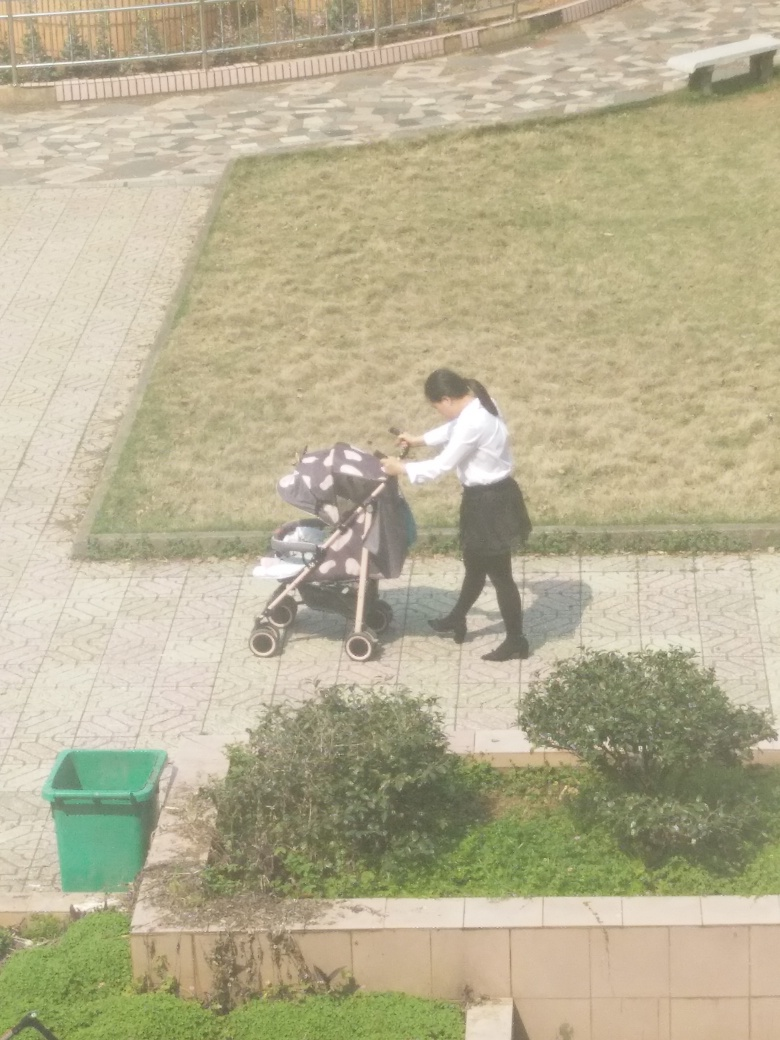It seems quite sunny, but the person is not wearing sunglasses. Can we infer something from this? While sunglasses are common on sunny days to protect eyes from glare, not everyone chooses to wear them. This could be due to personal preference, not having a pair on hand, or not being bothered by the brightness. It's also possible they just stepped out for a moment and didn't consider it necessary. 